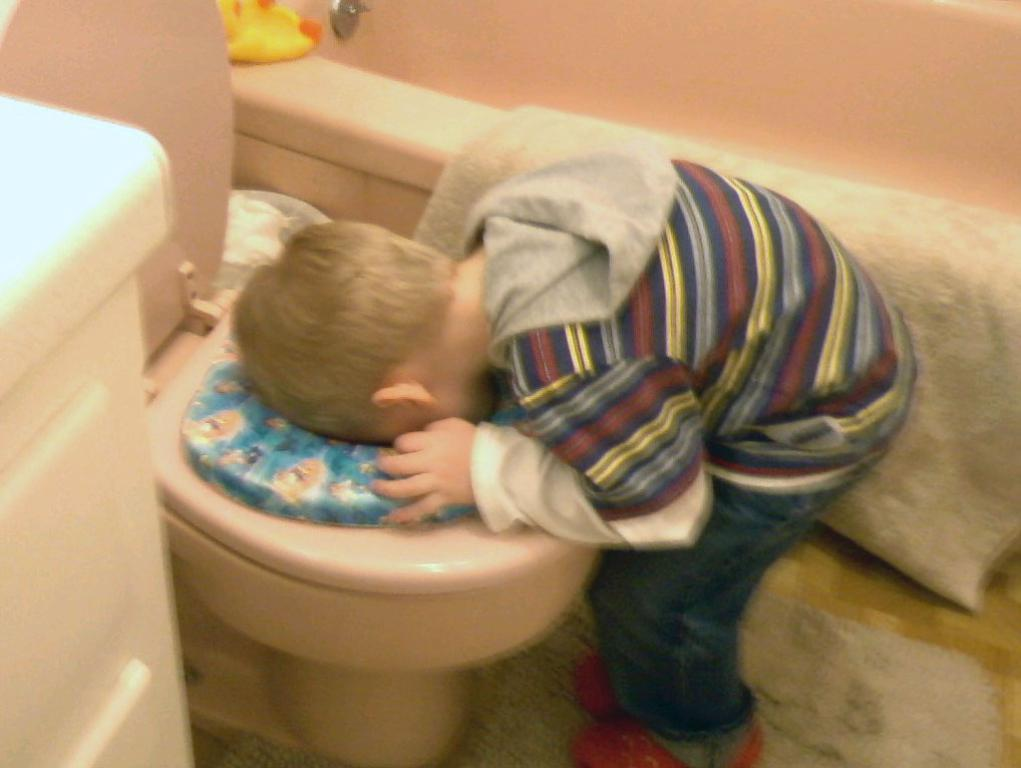What type of furniture is present in the image? There is a commode in the image. Can you describe who or what is in the image besides the commode? There is a boy in the image. What type of crate is being used to light the match in the image? There is no crate or match present in the image. What type of linen is draped over the commode in the image? There is no linen draped over the commode in the image. 